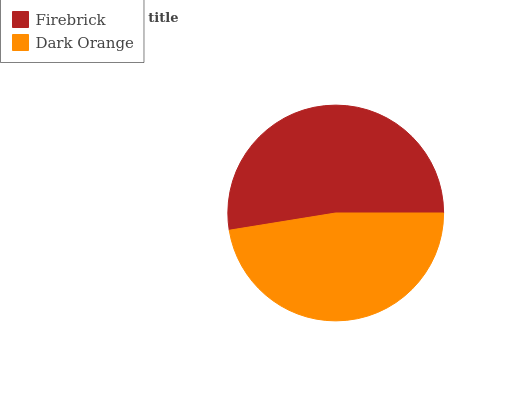Is Dark Orange the minimum?
Answer yes or no. Yes. Is Firebrick the maximum?
Answer yes or no. Yes. Is Dark Orange the maximum?
Answer yes or no. No. Is Firebrick greater than Dark Orange?
Answer yes or no. Yes. Is Dark Orange less than Firebrick?
Answer yes or no. Yes. Is Dark Orange greater than Firebrick?
Answer yes or no. No. Is Firebrick less than Dark Orange?
Answer yes or no. No. Is Firebrick the high median?
Answer yes or no. Yes. Is Dark Orange the low median?
Answer yes or no. Yes. Is Dark Orange the high median?
Answer yes or no. No. Is Firebrick the low median?
Answer yes or no. No. 